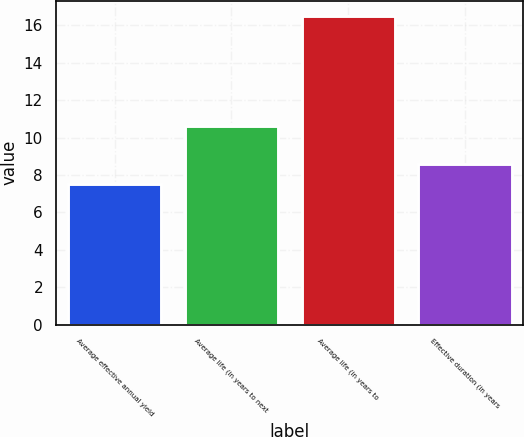Convert chart. <chart><loc_0><loc_0><loc_500><loc_500><bar_chart><fcel>Average effective annual yield<fcel>Average life (in years to next<fcel>Average life (in years to<fcel>Effective duration (in years<nl><fcel>7.5<fcel>10.6<fcel>16.5<fcel>8.6<nl></chart> 